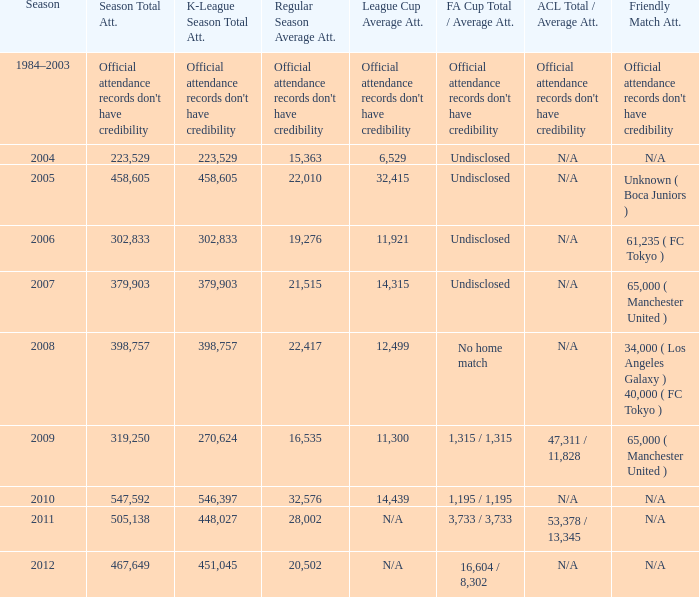What was attendance of the whole season when the average attendance for League Cup was 32,415? 458605.0. 